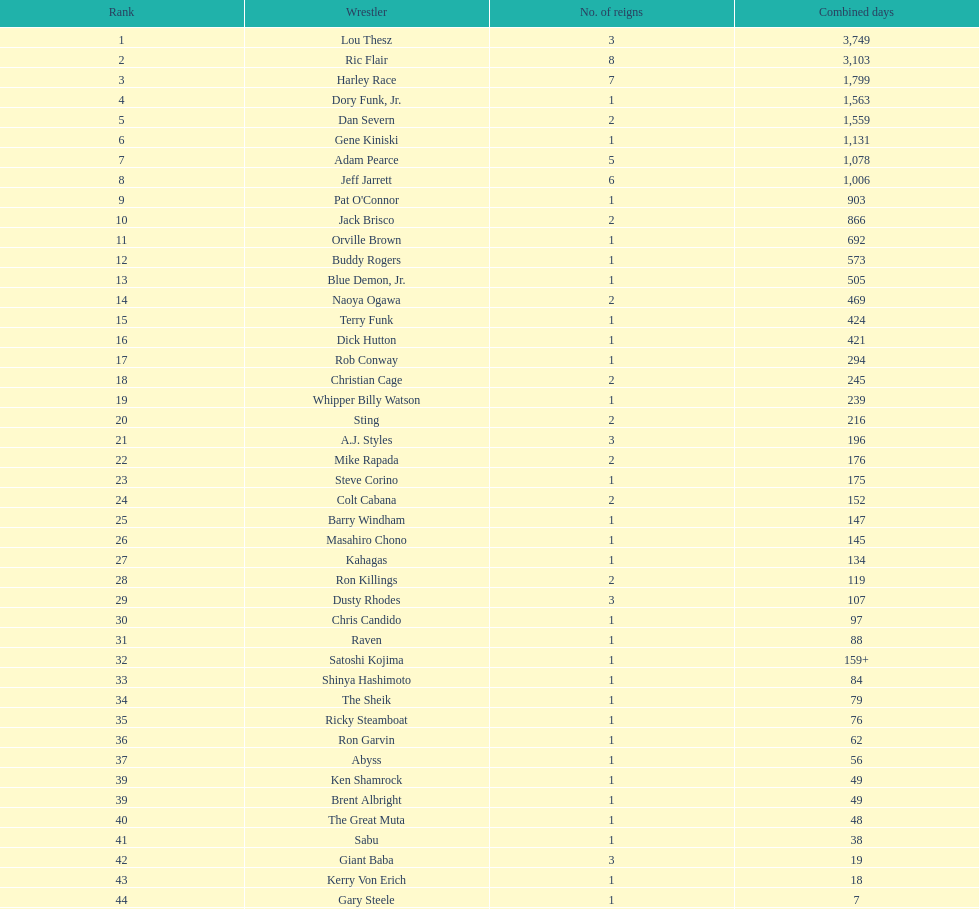Who had a longer reign as nwa world heavyweight champion, gene kiniski or ric flair? Ric Flair. 